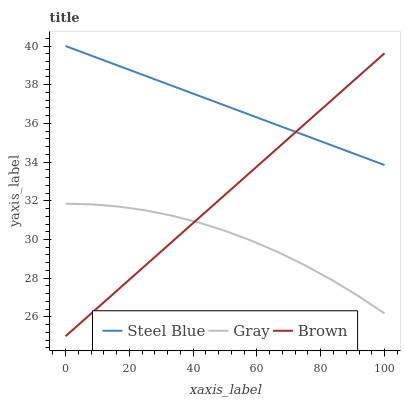Does Gray have the minimum area under the curve?
Answer yes or no. Yes. Does Steel Blue have the maximum area under the curve?
Answer yes or no. Yes. Does Brown have the minimum area under the curve?
Answer yes or no. No. Does Brown have the maximum area under the curve?
Answer yes or no. No. Is Steel Blue the smoothest?
Answer yes or no. Yes. Is Gray the roughest?
Answer yes or no. Yes. Is Brown the smoothest?
Answer yes or no. No. Is Brown the roughest?
Answer yes or no. No. Does Steel Blue have the lowest value?
Answer yes or no. No. Does Brown have the highest value?
Answer yes or no. No. Is Gray less than Steel Blue?
Answer yes or no. Yes. Is Steel Blue greater than Gray?
Answer yes or no. Yes. Does Gray intersect Steel Blue?
Answer yes or no. No. 